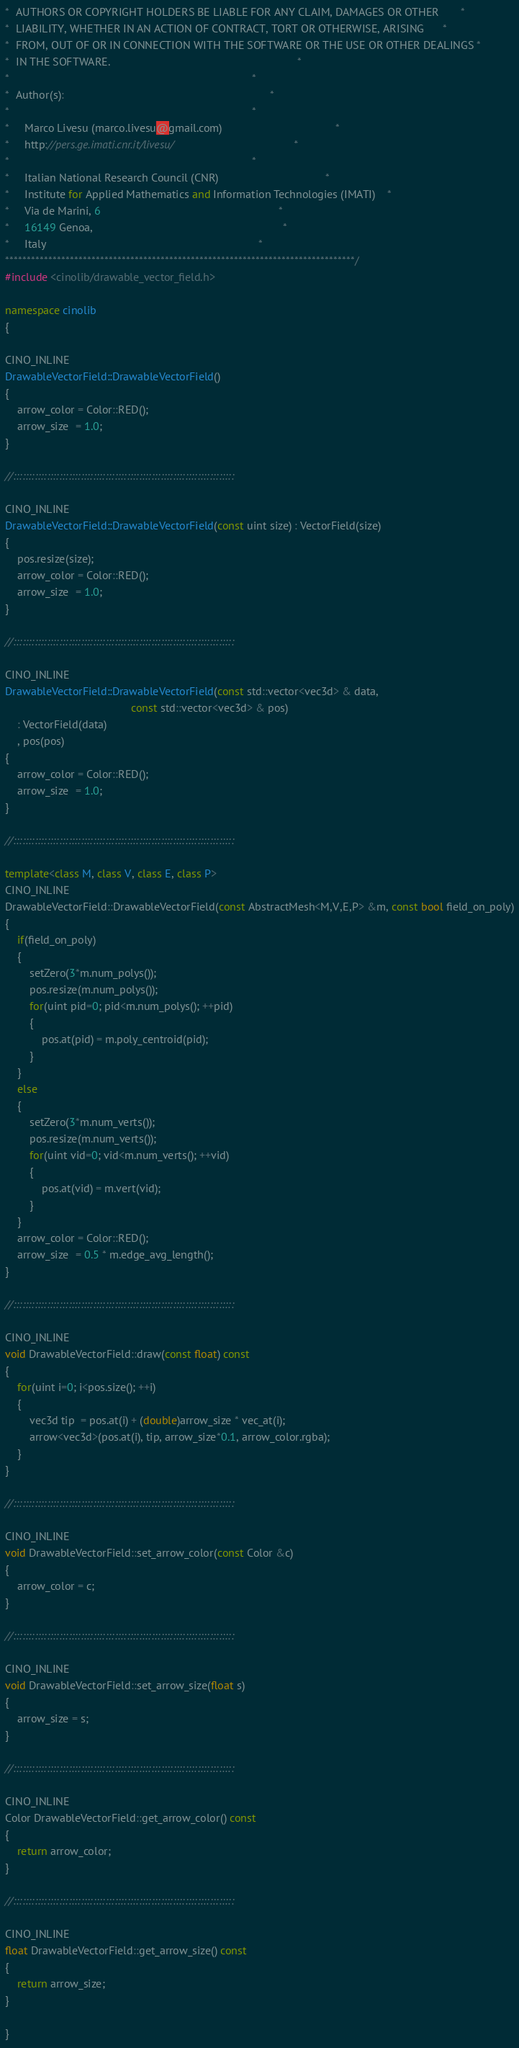Convert code to text. <code><loc_0><loc_0><loc_500><loc_500><_C++_>*  AUTHORS OR COPYRIGHT HOLDERS BE LIABLE FOR ANY CLAIM, DAMAGES OR OTHER       *
*  LIABILITY, WHETHER IN AN ACTION OF CONTRACT, TORT OR OTHERWISE, ARISING      *
*  FROM, OUT OF OR IN CONNECTION WITH THE SOFTWARE OR THE USE OR OTHER DEALINGS *
*  IN THE SOFTWARE.                                                             *
*                                                                               *
*  Author(s):                                                                   *
*                                                                               *
*     Marco Livesu (marco.livesu@gmail.com)                                     *
*     http://pers.ge.imati.cnr.it/livesu/                                       *
*                                                                               *
*     Italian National Research Council (CNR)                                   *
*     Institute for Applied Mathematics and Information Technologies (IMATI)    *
*     Via de Marini, 6                                                          *
*     16149 Genoa,                                                              *
*     Italy                                                                     *
*********************************************************************************/
#include <cinolib/drawable_vector_field.h>

namespace cinolib
{

CINO_INLINE
DrawableVectorField::DrawableVectorField()
{
    arrow_color = Color::RED();
    arrow_size  = 1.0;
}

//::::::::::::::::::::::::::::::::::::::::::::::::::::::::::::::::::::::::

CINO_INLINE
DrawableVectorField::DrawableVectorField(const uint size) : VectorField(size)
{
    pos.resize(size);
    arrow_color = Color::RED();
    arrow_size  = 1.0;
}

//::::::::::::::::::::::::::::::::::::::::::::::::::::::::::::::::::::::::

CINO_INLINE
DrawableVectorField::DrawableVectorField(const std::vector<vec3d> & data,
                                         const std::vector<vec3d> & pos)
    : VectorField(data)
    , pos(pos)
{
    arrow_color = Color::RED();
    arrow_size  = 1.0;
}

//::::::::::::::::::::::::::::::::::::::::::::::::::::::::::::::::::::::::

template<class M, class V, class E, class P>
CINO_INLINE
DrawableVectorField::DrawableVectorField(const AbstractMesh<M,V,E,P> &m, const bool field_on_poly)
{
    if(field_on_poly)
    {
        setZero(3*m.num_polys());
        pos.resize(m.num_polys());
        for(uint pid=0; pid<m.num_polys(); ++pid)
        {
            pos.at(pid) = m.poly_centroid(pid);
        }
    }
    else
    {
        setZero(3*m.num_verts());
        pos.resize(m.num_verts());
        for(uint vid=0; vid<m.num_verts(); ++vid)
        {
            pos.at(vid) = m.vert(vid);
        }
    }
    arrow_color = Color::RED();
    arrow_size  = 0.5 * m.edge_avg_length();
}

//::::::::::::::::::::::::::::::::::::::::::::::::::::::::::::::::::::::::

CINO_INLINE
void DrawableVectorField::draw(const float) const
{
    for(uint i=0; i<pos.size(); ++i)
    {
        vec3d tip  = pos.at(i) + (double)arrow_size * vec_at(i);
        arrow<vec3d>(pos.at(i), tip, arrow_size*0.1, arrow_color.rgba);
    }
}

//::::::::::::::::::::::::::::::::::::::::::::::::::::::::::::::::::::::::

CINO_INLINE
void DrawableVectorField::set_arrow_color(const Color &c)
{
    arrow_color = c;
}

//::::::::::::::::::::::::::::::::::::::::::::::::::::::::::::::::::::::::

CINO_INLINE
void DrawableVectorField::set_arrow_size(float s)
{
    arrow_size = s;
}

//::::::::::::::::::::::::::::::::::::::::::::::::::::::::::::::::::::::::

CINO_INLINE
Color DrawableVectorField::get_arrow_color() const
{
    return arrow_color;
}

//::::::::::::::::::::::::::::::::::::::::::::::::::::::::::::::::::::::::

CINO_INLINE
float DrawableVectorField::get_arrow_size() const
{
    return arrow_size;
}

}
</code> 